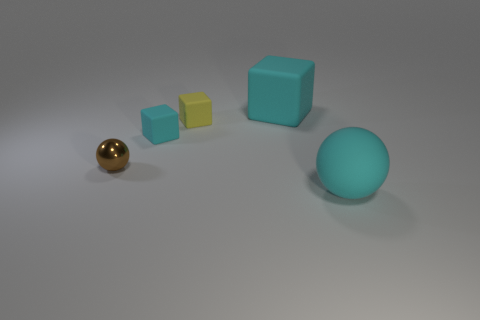There is a big cyan thing that is on the left side of the cyan rubber thing right of the large cyan matte object that is on the left side of the big cyan rubber ball; what is its shape?
Provide a short and direct response. Cube. How many things are either cyan rubber objects that are to the left of the yellow rubber object or spheres to the right of the tiny yellow matte cube?
Your answer should be compact. 2. There is a ball that is on the left side of the thing in front of the tiny metallic thing; what size is it?
Your answer should be compact. Small. There is a sphere to the right of the yellow rubber cube; is its color the same as the large block?
Your answer should be compact. Yes. Are there any other tiny yellow matte things that have the same shape as the tiny yellow matte thing?
Make the answer very short. No. There is a metal thing that is the same size as the yellow cube; what color is it?
Provide a short and direct response. Brown. What size is the ball that is to the left of the cyan ball?
Provide a short and direct response. Small. Is there a tiny brown sphere behind the rubber block behind the yellow rubber cube?
Provide a succinct answer. No. Is the sphere that is behind the cyan rubber sphere made of the same material as the small cyan cube?
Your answer should be compact. No. What number of things are in front of the tiny yellow matte thing and to the right of the tiny cyan object?
Give a very brief answer. 1. 